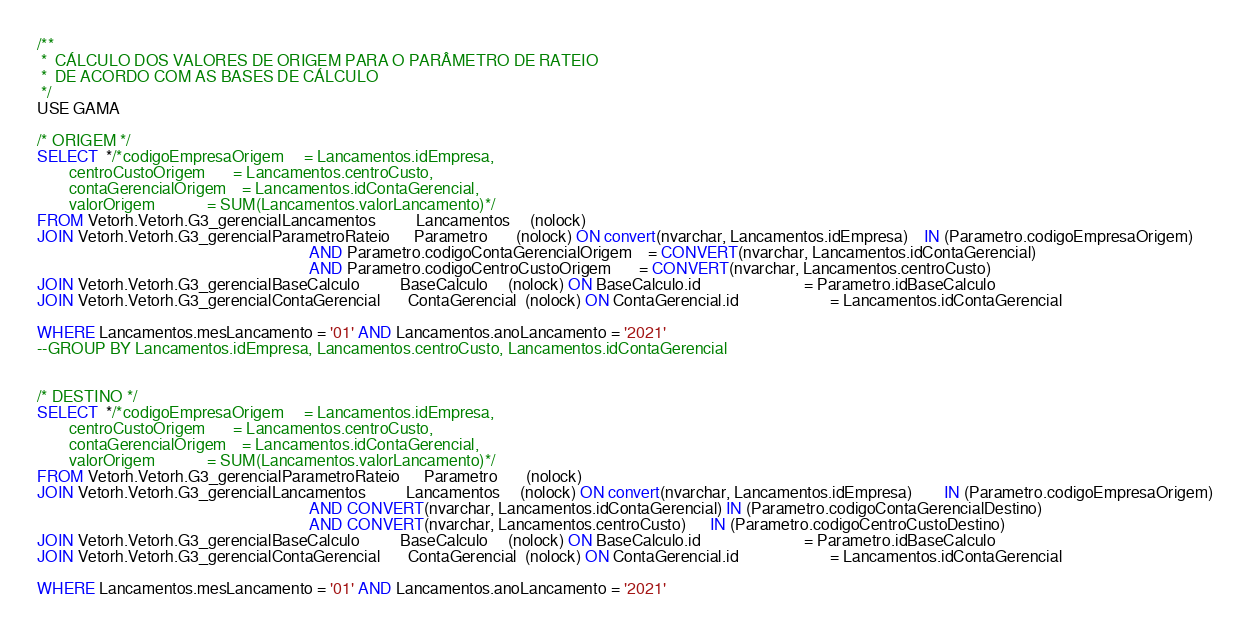Convert code to text. <code><loc_0><loc_0><loc_500><loc_500><_SQL_>/**
 *  CÁLCULO DOS VALORES DE ORIGEM PARA O PARÂMETRO DE RATEIO
 *  DE ACORDO COM AS BASES DE CÁLCULO
 */
USE GAMA

/* ORIGEM */
SELECT  */*codigoEmpresaOrigem     = Lancamentos.idEmpresa,
        centroCustoOrigem       = Lancamentos.centroCusto,
        contaGerencialOrigem    = Lancamentos.idContaGerencial,
        valorOrigem             = SUM(Lancamentos.valorLancamento)*/
FROM Vetorh.Vetorh.G3_gerencialLancamentos          Lancamentos     (nolock)   
JOIN Vetorh.Vetorh.G3_gerencialParametroRateio      Parametro       (nolock) ON convert(nvarchar, Lancamentos.idEmpresa)    IN (Parametro.codigoEmpresaOrigem)
                                                                    AND Parametro.codigoContaGerencialOrigem    = CONVERT(nvarchar, Lancamentos.idContaGerencial)
                                                                    AND Parametro.codigoCentroCustoOrigem       = CONVERT(nvarchar, Lancamentos.centroCusto)
JOIN Vetorh.Vetorh.G3_gerencialBaseCalculo          BaseCalculo     (nolock) ON BaseCalculo.id                          = Parametro.idBaseCalculo
JOIN Vetorh.Vetorh.G3_gerencialContaGerencial       ContaGerencial  (nolock) ON ContaGerencial.id                       = Lancamentos.idContaGerencial

WHERE Lancamentos.mesLancamento = '01' AND Lancamentos.anoLancamento = '2021'
--GROUP BY Lancamentos.idEmpresa, Lancamentos.centroCusto, Lancamentos.idContaGerencial


/* DESTINO */
SELECT  */*codigoEmpresaOrigem     = Lancamentos.idEmpresa,
        centroCustoOrigem       = Lancamentos.centroCusto,
        contaGerencialOrigem    = Lancamentos.idContaGerencial,
        valorOrigem             = SUM(Lancamentos.valorLancamento)*/
FROM Vetorh.Vetorh.G3_gerencialParametroRateio      Parametro       (nolock)   
JOIN Vetorh.Vetorh.G3_gerencialLancamentos          Lancamentos     (nolock) ON convert(nvarchar, Lancamentos.idEmpresa)        IN (Parametro.codigoEmpresaOrigem)
                                                                    AND CONVERT(nvarchar, Lancamentos.idContaGerencial) IN (Parametro.codigoContaGerencialDestino)
                                                                    AND CONVERT(nvarchar, Lancamentos.centroCusto)      IN (Parametro.codigoCentroCustoDestino)
JOIN Vetorh.Vetorh.G3_gerencialBaseCalculo          BaseCalculo     (nolock) ON BaseCalculo.id                          = Parametro.idBaseCalculo
JOIN Vetorh.Vetorh.G3_gerencialContaGerencial       ContaGerencial  (nolock) ON ContaGerencial.id                       = Lancamentos.idContaGerencial

WHERE Lancamentos.mesLancamento = '01' AND Lancamentos.anoLancamento = '2021'
</code> 